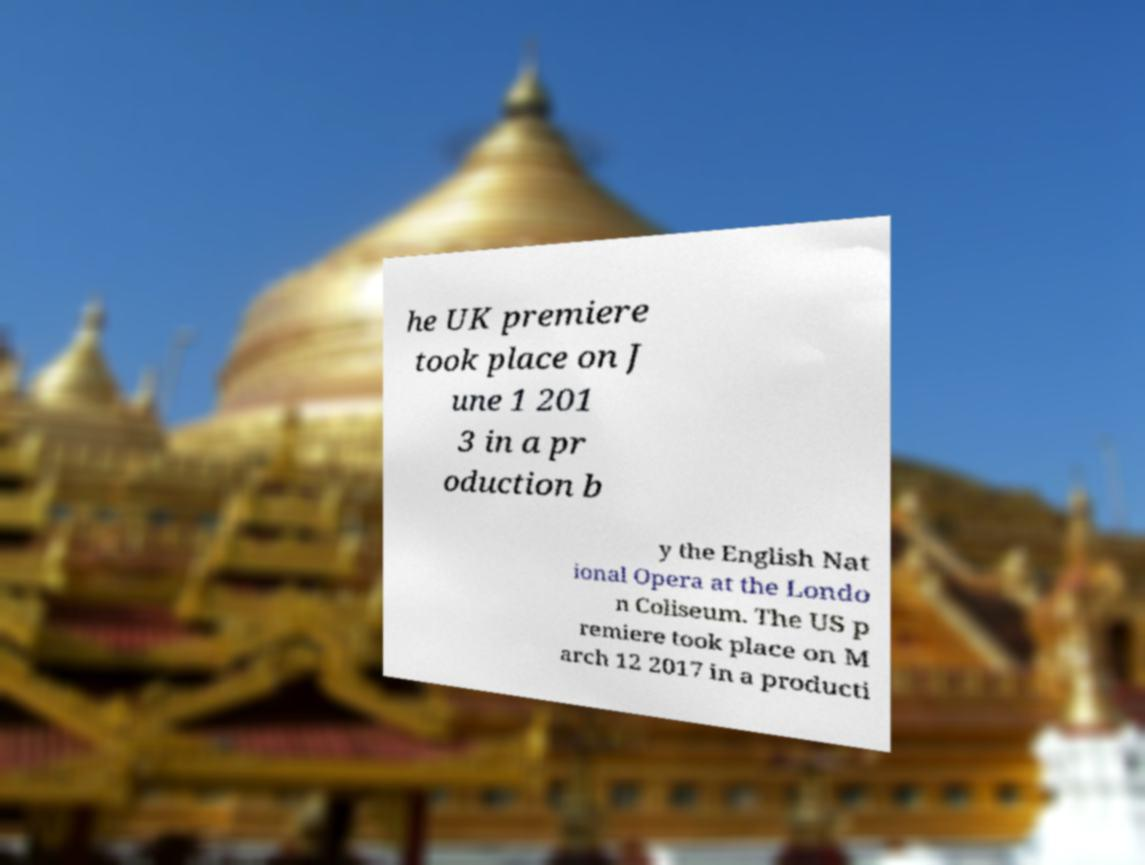Could you assist in decoding the text presented in this image and type it out clearly? he UK premiere took place on J une 1 201 3 in a pr oduction b y the English Nat ional Opera at the Londo n Coliseum. The US p remiere took place on M arch 12 2017 in a producti 